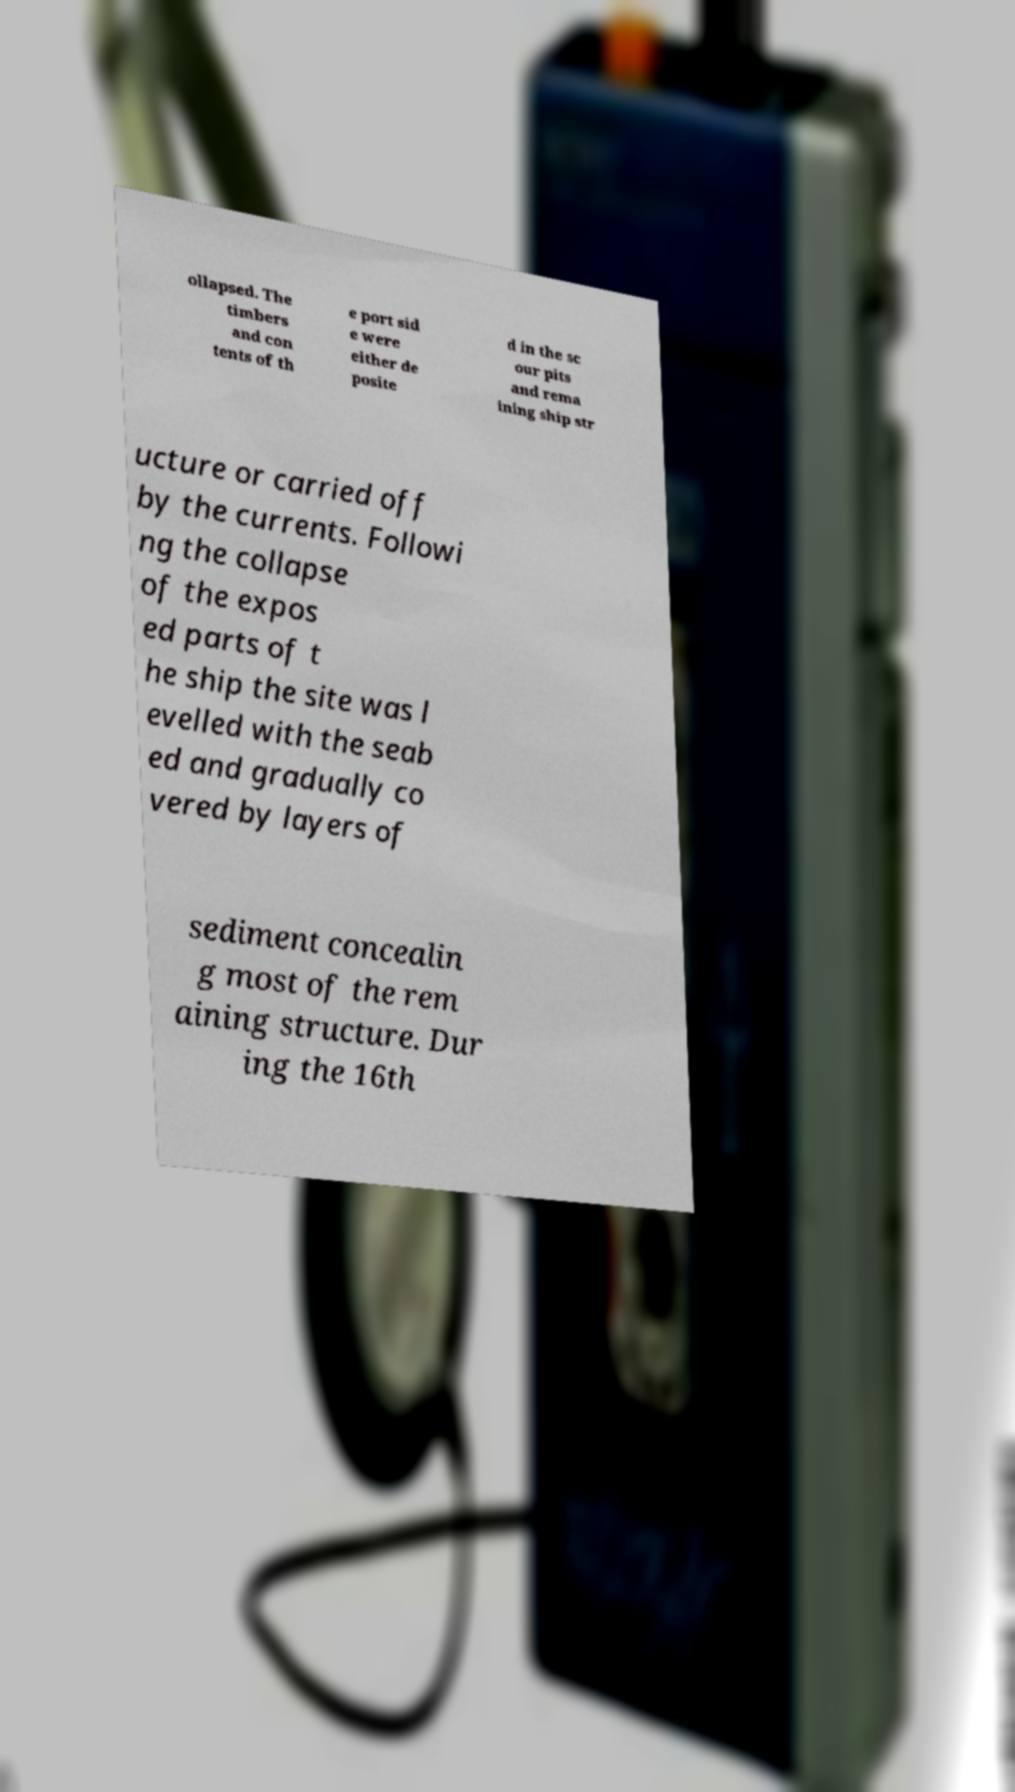Can you read and provide the text displayed in the image?This photo seems to have some interesting text. Can you extract and type it out for me? ollapsed. The timbers and con tents of th e port sid e were either de posite d in the sc our pits and rema ining ship str ucture or carried off by the currents. Followi ng the collapse of the expos ed parts of t he ship the site was l evelled with the seab ed and gradually co vered by layers of sediment concealin g most of the rem aining structure. Dur ing the 16th 